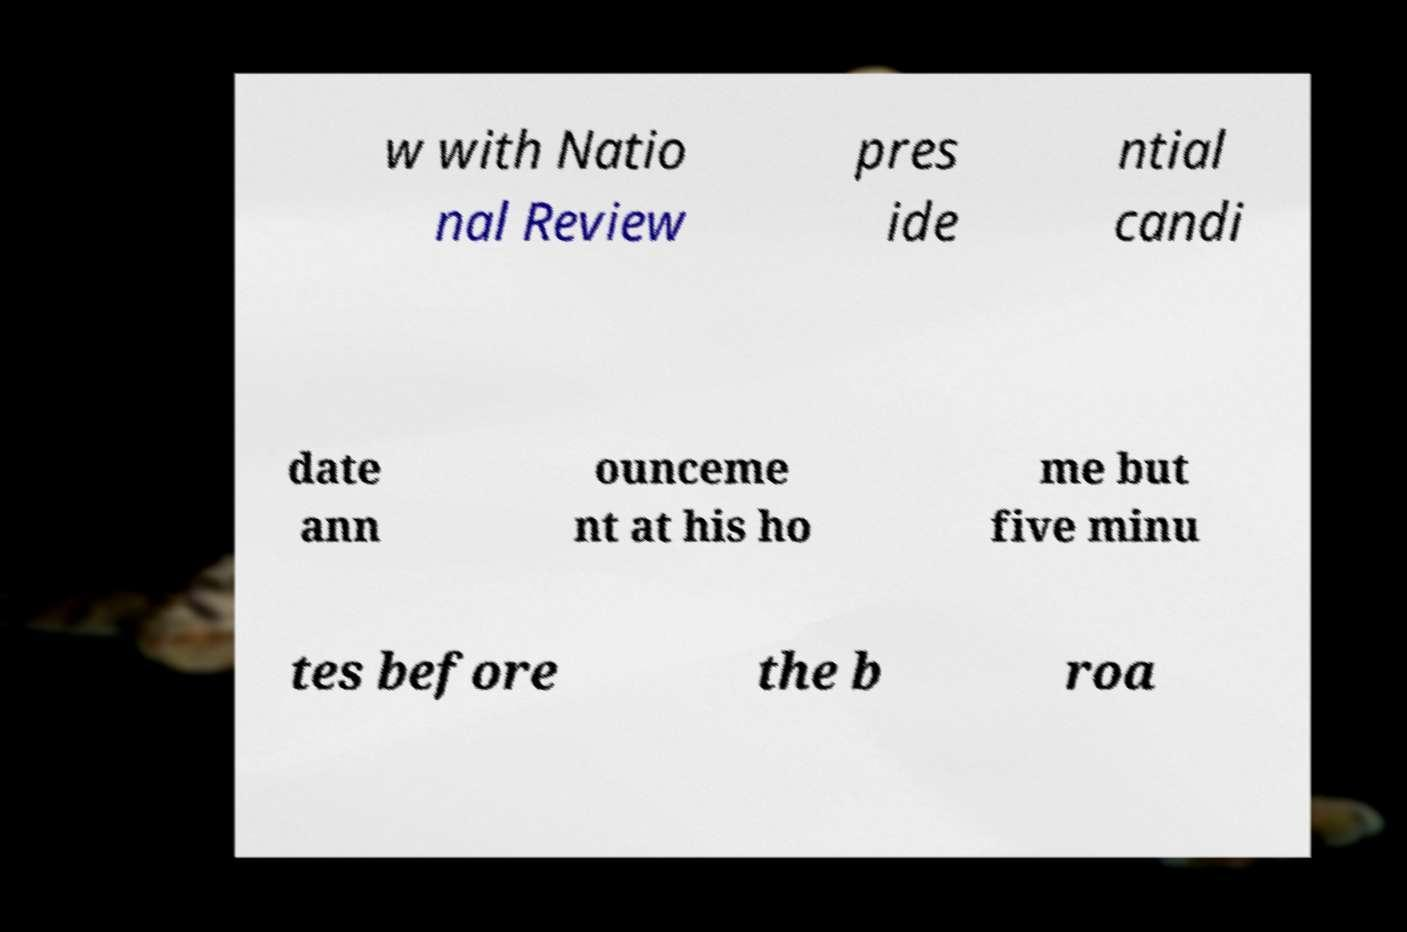Could you extract and type out the text from this image? w with Natio nal Review pres ide ntial candi date ann ounceme nt at his ho me but five minu tes before the b roa 